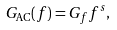Convert formula to latex. <formula><loc_0><loc_0><loc_500><loc_500>G _ { \text {AC} } ( f ) = G _ { f } f ^ { s } ,</formula> 